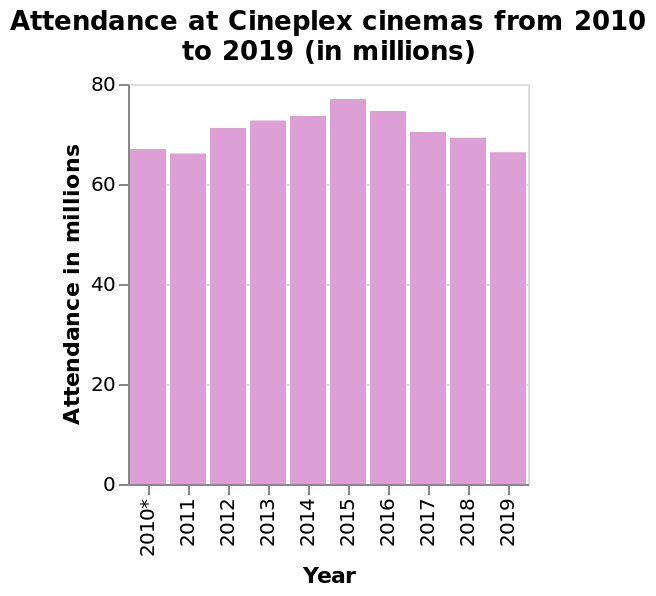<image>
What is the minimum attendance recorded at cineplex cinemas from 2010 to 2019? The minimum attendance recorded at cineplex cinemas from 2010 to 2019 is above 65 million people per year. 